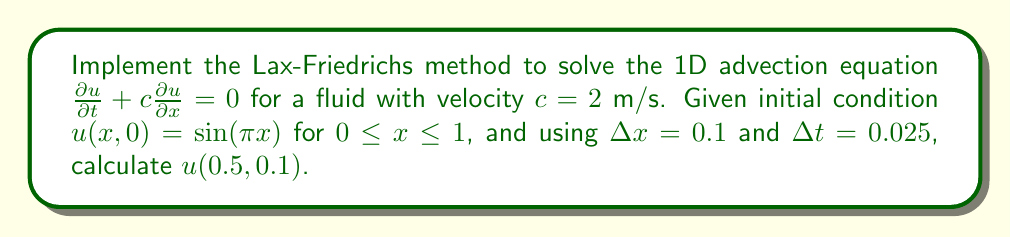Teach me how to tackle this problem. 1) The Lax-Friedrichs method for the 1D advection equation is given by:

   $$u_i^{n+1} = \frac{1}{2}(u_{i+1}^n + u_{i-1}^n) - \frac{c\Delta t}{2\Delta x}(u_{i+1}^n - u_{i-1}^n)$$

2) Calculate the Courant number: $\nu = \frac{c\Delta t}{\Delta x} = \frac{2 \cdot 0.025}{0.1} = 0.5$

3) Initialize the grid:
   - Spatial points: $x_i = i\Delta x$ for $i = 0, 1, ..., 10$
   - Initial condition: $u_i^0 = \sin(\pi x_i)$

4) We need to calculate $u(0.5, 0.1)$, which corresponds to $u_5^4$ (5th spatial point, 4th time step).

5) Apply the Lax-Friedrichs method iteratively:

   For $n = 0$ to $3$:
   $$u_i^{n+1} = \frac{1}{2}(u_{i+1}^n + u_{i-1}^n) - 0.25(u_{i+1}^n - u_{i-1}^n)$$

6) After 4 time steps, we arrive at $u_5^4$.

7) Implementing this numerically (which a data scientist would typically do using a programming language), we find:

   $u_5^4 \approx 0.7691$
Answer: 0.7691 